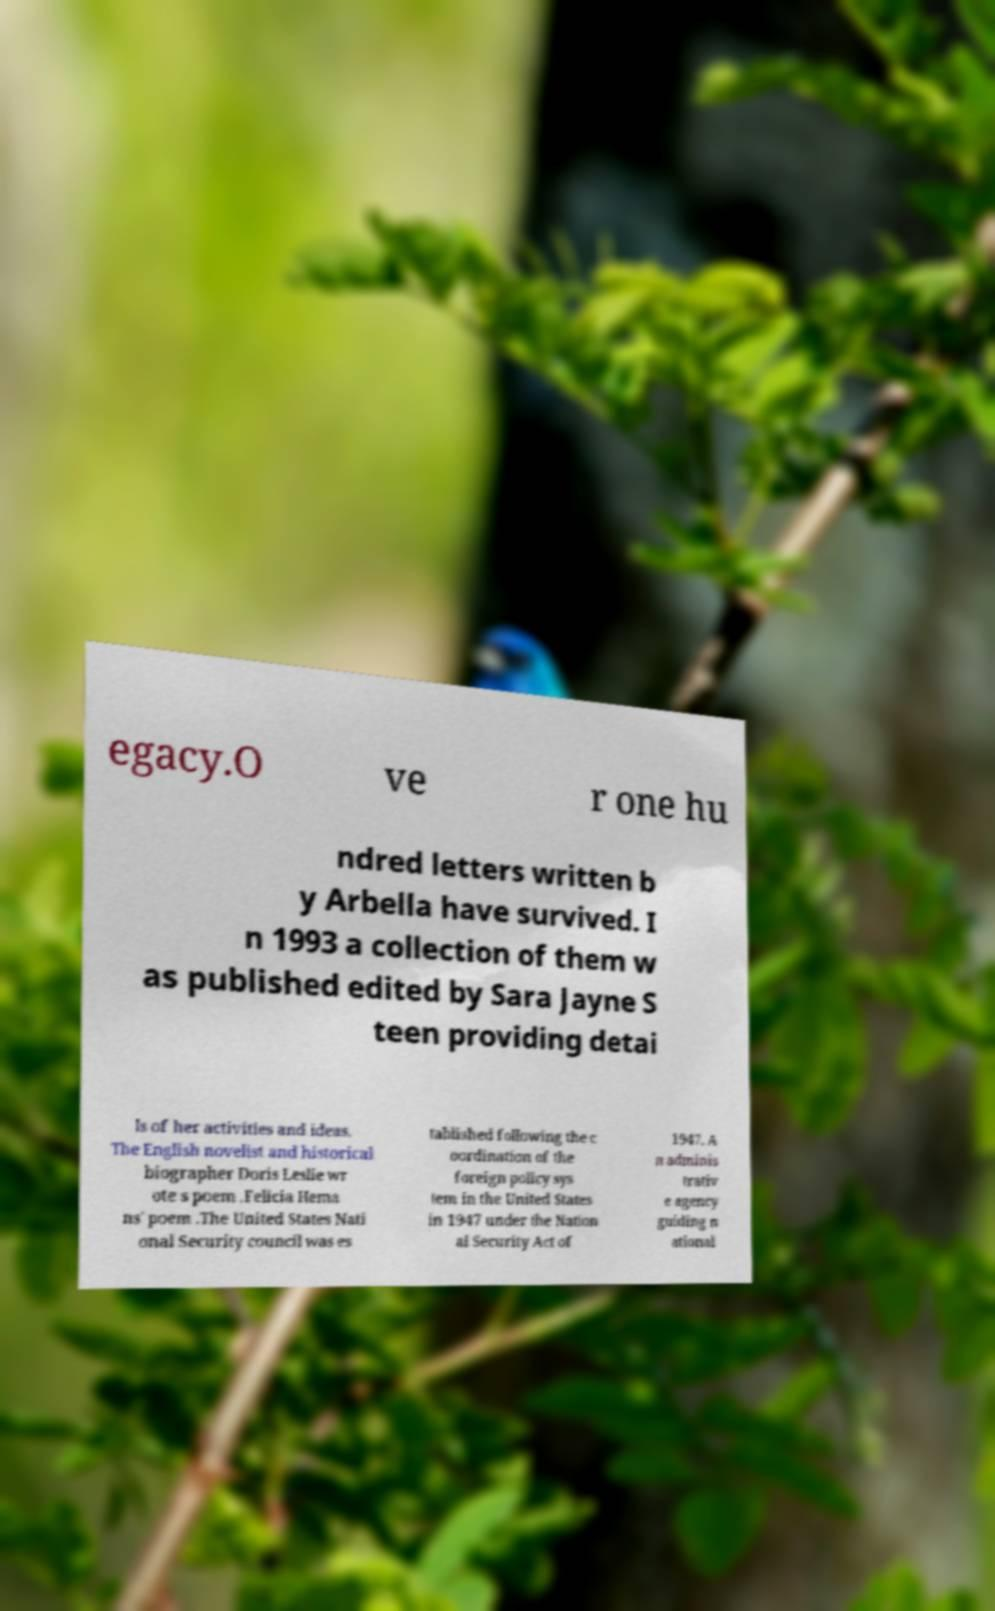Could you extract and type out the text from this image? egacy.O ve r one hu ndred letters written b y Arbella have survived. I n 1993 a collection of them w as published edited by Sara Jayne S teen providing detai ls of her activities and ideas. The English novelist and historical biographer Doris Leslie wr ote s poem .Felicia Hema ns' poem .The United States Nati onal Security council was es tablished following the c oordination of the foreign policy sys tem in the United States in 1947 under the Nation al Security Act of 1947. A n adminis trativ e agency guiding n ational 